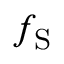<formula> <loc_0><loc_0><loc_500><loc_500>f _ { S }</formula> 